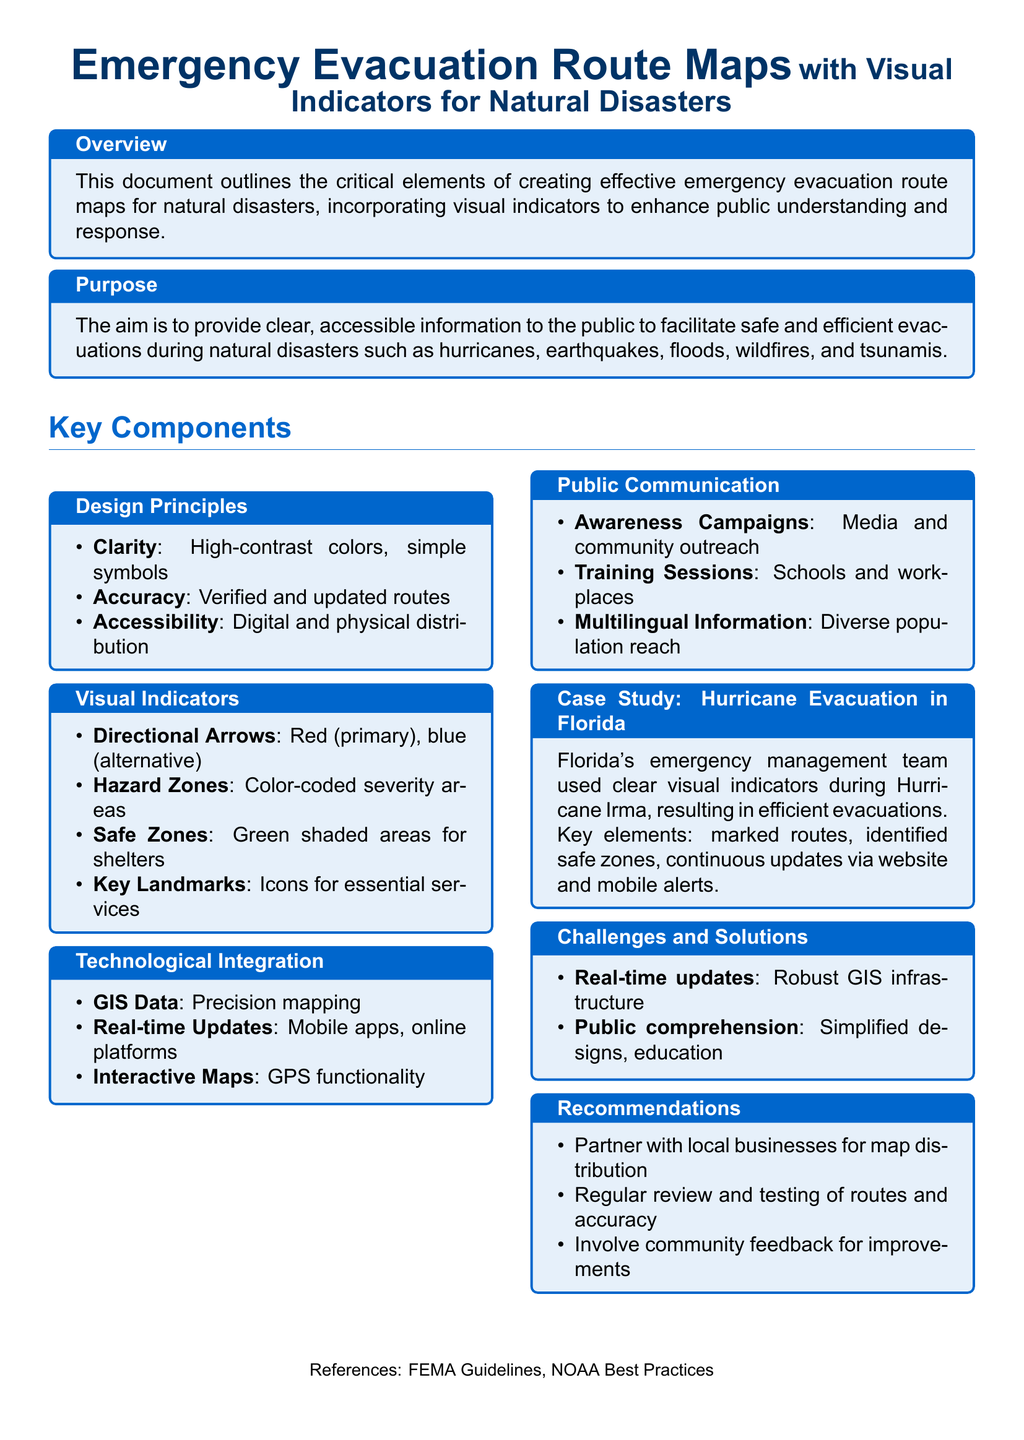What is the main purpose of the document? The purpose is outlined in the section labeled "Purpose," highlighting the goal of providing clear information for safe evacuations during natural disasters.
Answer: To facilitate safe and efficient evacuations What color represents primary directional arrows? The visual indicators section states that red is designated for primary directional arrows.
Answer: Red Which natural disasters are specifically mentioned? The document lists hurricanes, earthquakes, floods, wildfires, and tsunamis under the purpose section.
Answer: Hurricanes, earthquakes, floods, wildfires, tsunamis What is one of the key components related to public communication? The public communication section identifies awareness campaigns as a significant aspect of engaging the public.
Answer: Awareness Campaigns How did Florida’s emergency management team improve evacuations during Hurricane Irma? The case study provides examples of improved evacuations through marked routes and continuous updates.
Answer: Marked routes, continuous updates What color indicates safe zones on the maps? The visual indicators section specifies that safe zones are represented by green shaded areas.
Answer: Green What type of data is used for precision mapping? The technological integration section mentions GIS data as essential for precision mapping.
Answer: GIS Data What is recommended for improving map distribution? The recommendations suggest partnering with local businesses for improved distribution strategies.
Answer: Partner with local businesses 